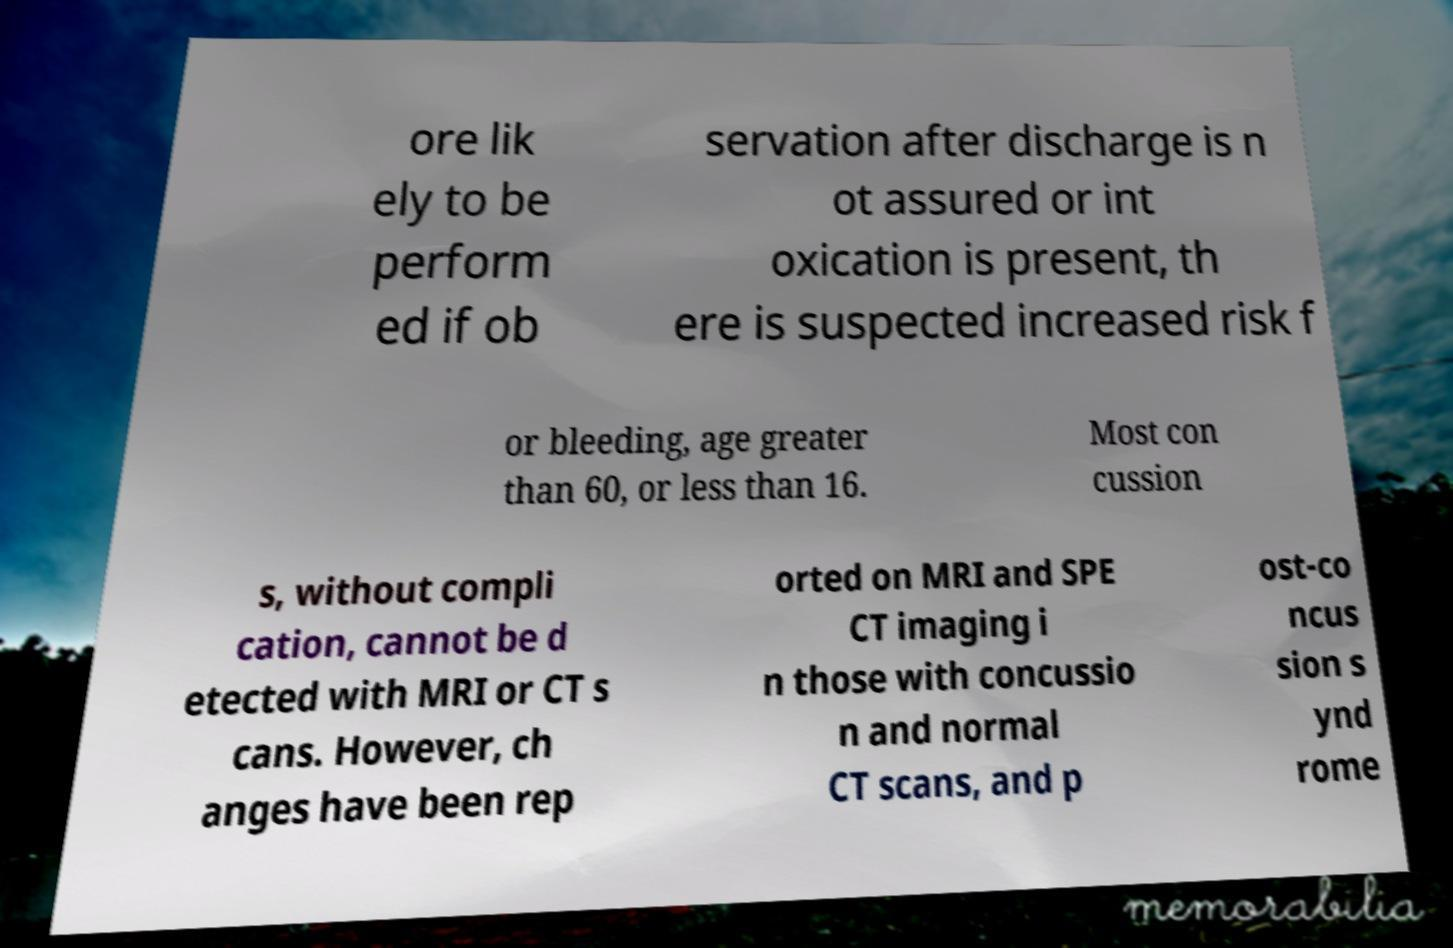Please read and relay the text visible in this image. What does it say? ore lik ely to be perform ed if ob servation after discharge is n ot assured or int oxication is present, th ere is suspected increased risk f or bleeding, age greater than 60, or less than 16. Most con cussion s, without compli cation, cannot be d etected with MRI or CT s cans. However, ch anges have been rep orted on MRI and SPE CT imaging i n those with concussio n and normal CT scans, and p ost-co ncus sion s ynd rome 